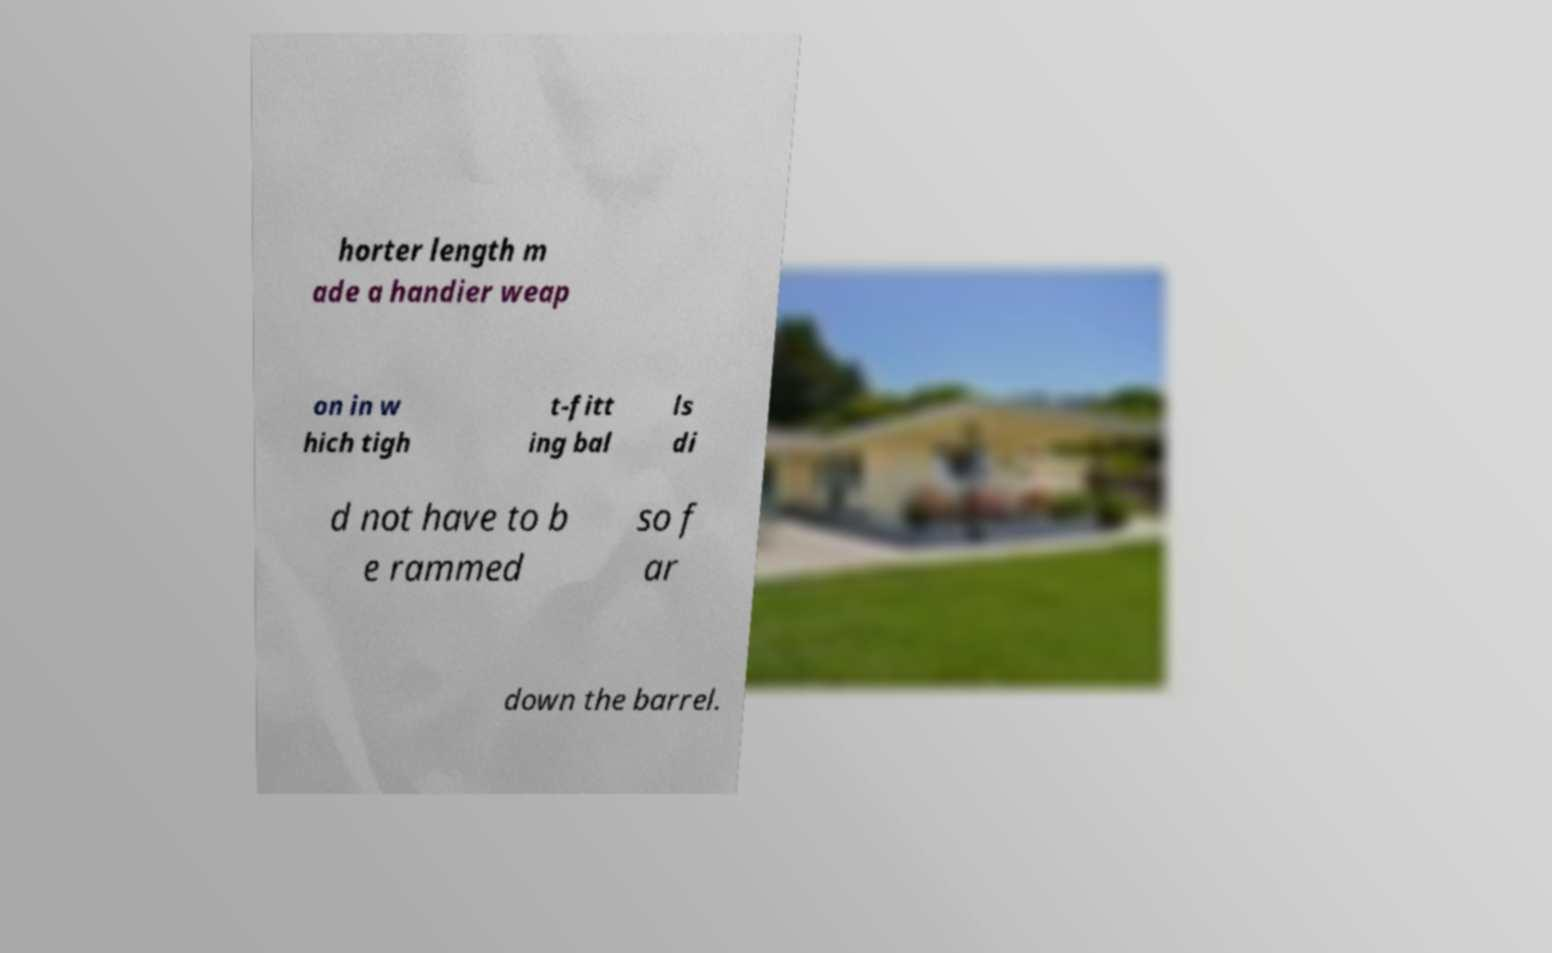There's text embedded in this image that I need extracted. Can you transcribe it verbatim? horter length m ade a handier weap on in w hich tigh t-fitt ing bal ls di d not have to b e rammed so f ar down the barrel. 